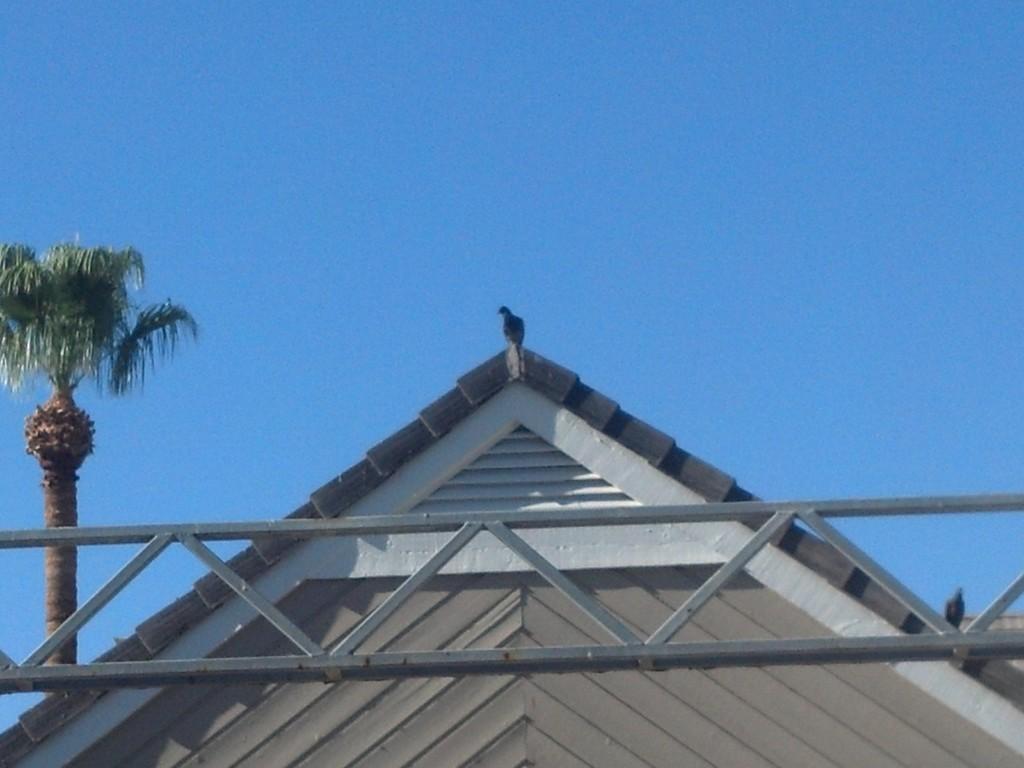Describe this image in one or two sentences. In this image there is a bird on the roof of a building, there is a metal structure and a coconut tree. In the background there is the sky. 